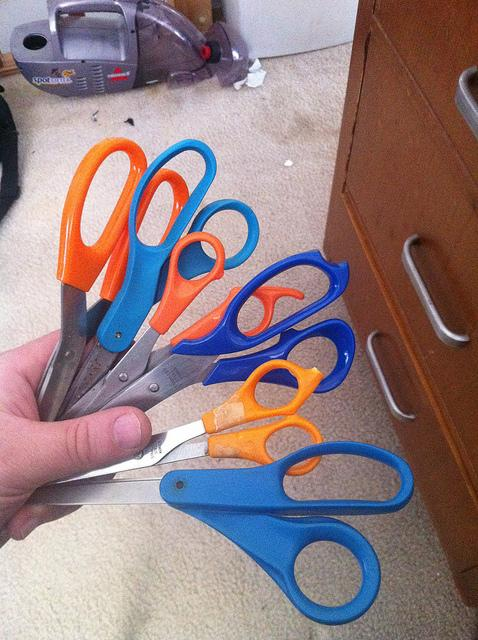What color is the smallest pair of scissors? orange 